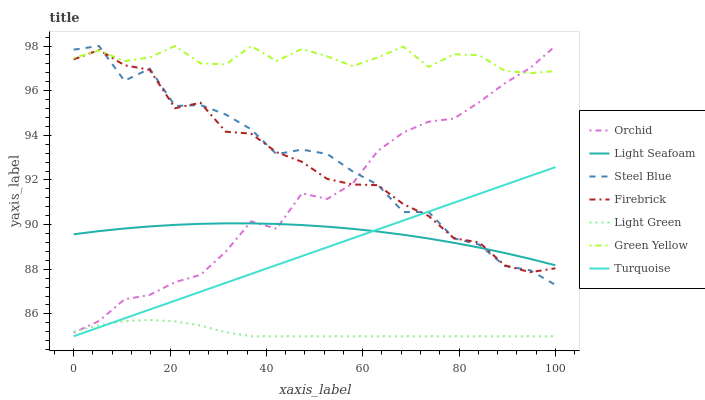Does Light Seafoam have the minimum area under the curve?
Answer yes or no. No. Does Light Seafoam have the maximum area under the curve?
Answer yes or no. No. Is Light Seafoam the smoothest?
Answer yes or no. No. Is Light Seafoam the roughest?
Answer yes or no. No. Does Light Seafoam have the lowest value?
Answer yes or no. No. Does Light Seafoam have the highest value?
Answer yes or no. No. Is Light Green less than Light Seafoam?
Answer yes or no. Yes. Is Green Yellow greater than Light Seafoam?
Answer yes or no. Yes. Does Light Green intersect Light Seafoam?
Answer yes or no. No. 